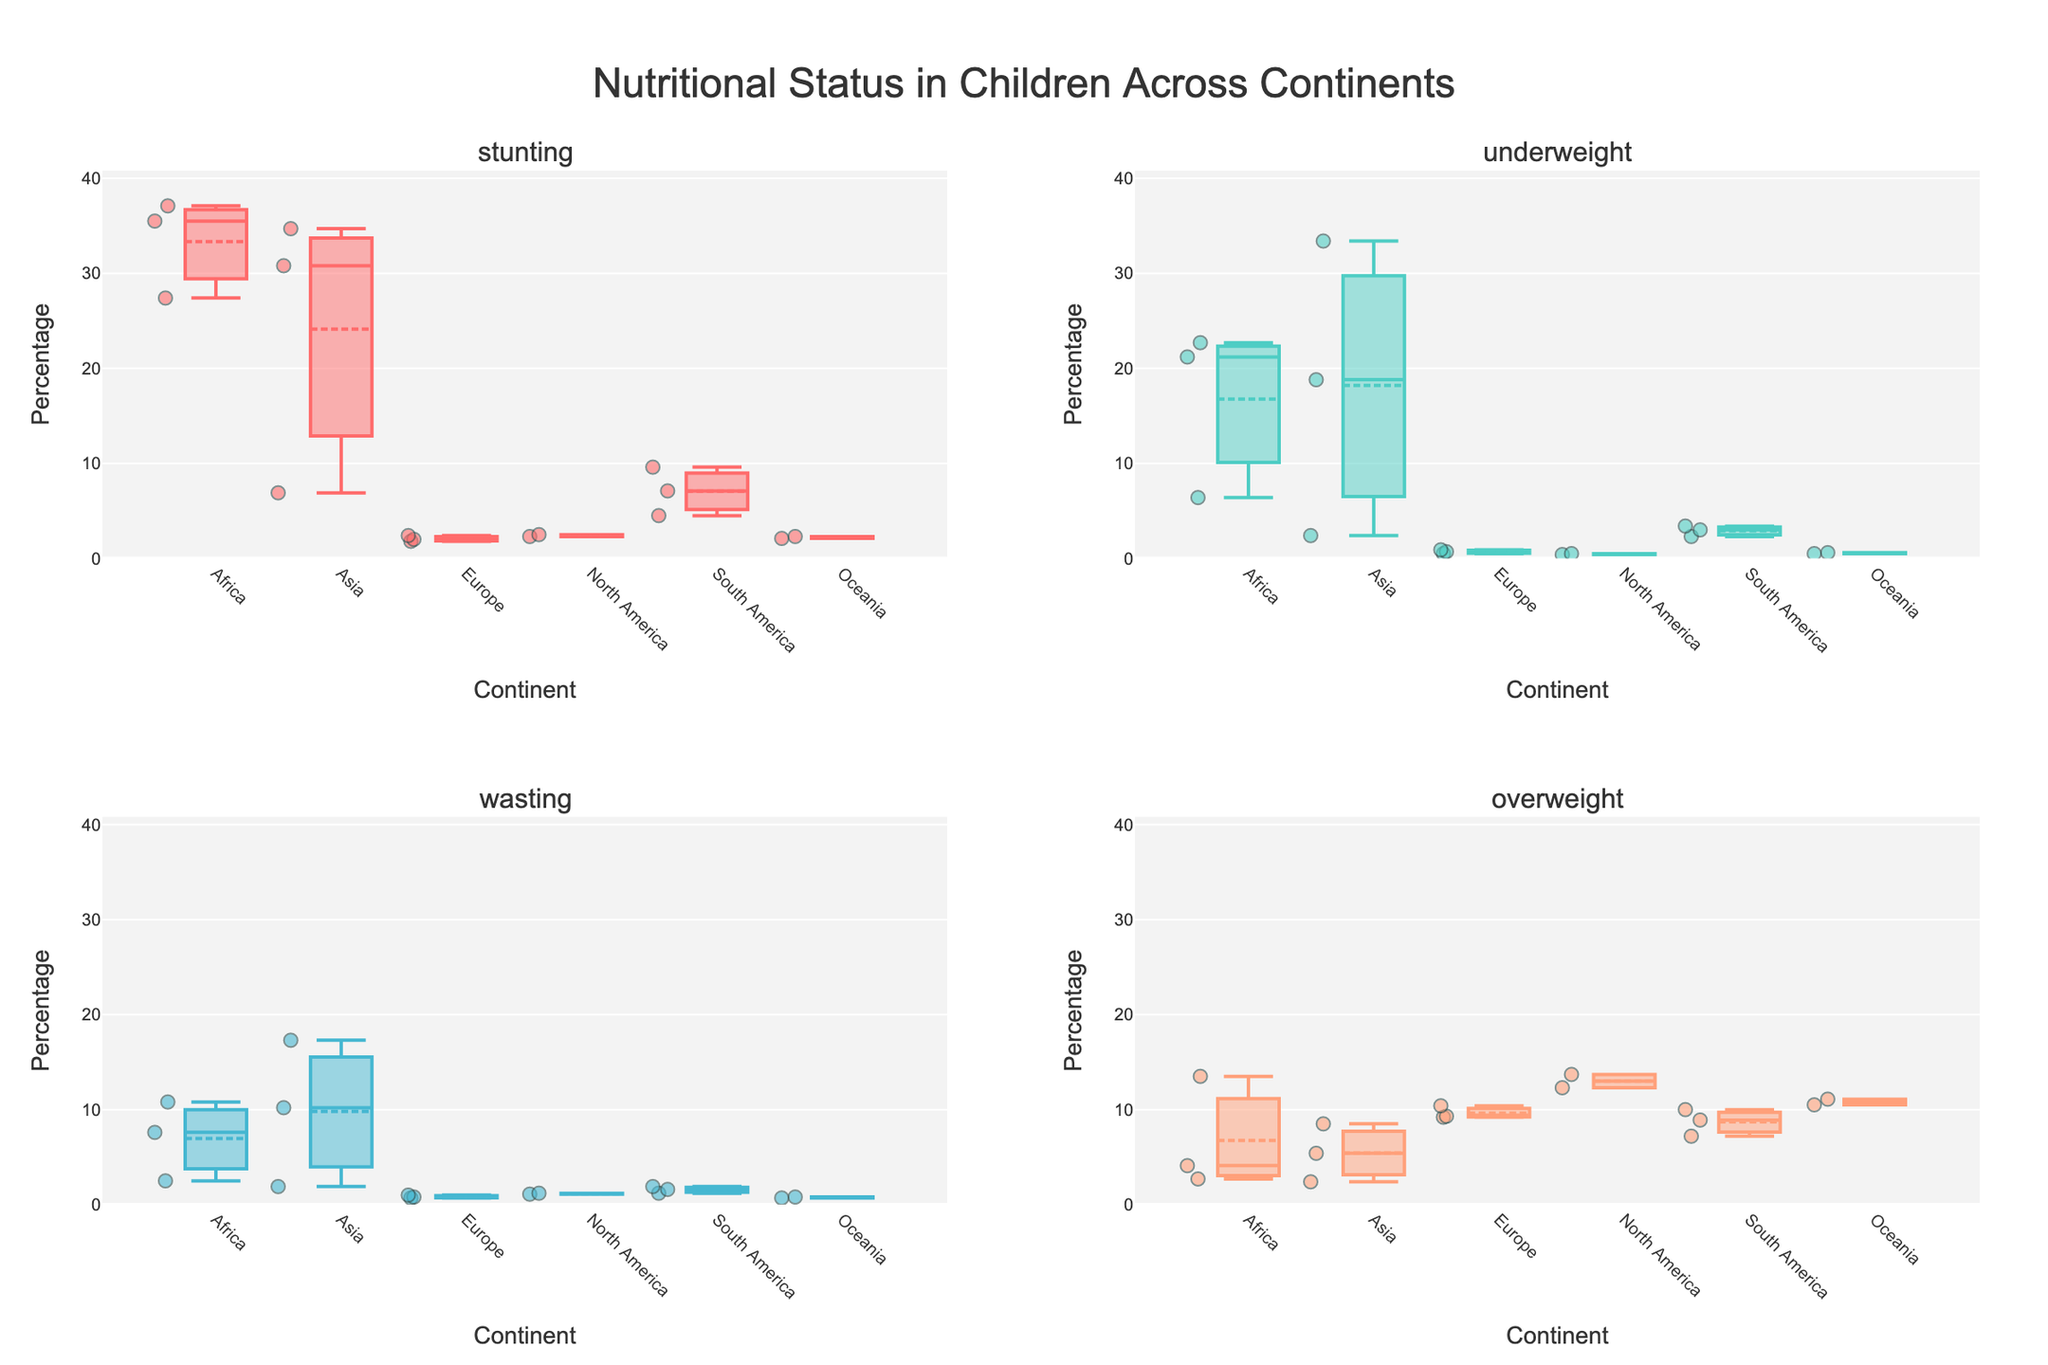What is the title of the figure? The title of the figure is displayed at the top and it reads "Nutritional Status in Children Across Continents".
Answer: Nutritional Status in Children Across Continents Which indicator has the highest value on average across continents? By examining the box plots, observe that "Stunting" tends to have higher median and mean values compared to "Underweight", "Wasting", and "Overweight".
Answer: Stunting Which continent has the highest median value for the indicator "Overweight"? The box plot for "Overweight" shows that North America has the highest median value among all continents.
Answer: North America What is the range of "Stunting" in Africa? The box plot for "Stunting" in Africa shows that its range (difference between the largest and smallest values) is from approximately 27.4% to 37.1%. Calculate: 37.1% - 27.4% = 9.7%.
Answer: 9.7% How does the median value of "Underweight" in Asia compare to that in Europe? The box plot for "Underweight" shows a much higher median value in Asia (with median around 18.8%) compared to Europe (which has a median close to 0.7%).
Answer: Higher in Asia Which continent has the most variation in "Wasting"? The "Wasting" box plot reveals that Asia has the widest spread with values ranging from approximately 1.9% to 17.3%, indicating the most variation.
Answer: Asia Is there any continent where the mean of "Underweight" is below 1%? Observing the means in the "Underweight" box plots, Europe, North America, and Oceania all display mean values below 1%.
Answer: Yes Which continent shows the least amount of "Wasting" on average? In the "Wasting" box plot, Europe displays the lowest mean value compared to other continents.
Answer: Europe How do the values of "Overweight" in Africa compare to those in Oceania? Comparing the box plots for "Overweight", Africa has lower values while Oceania shows higher values with medians and ranges.
Answer: Lower in Africa 